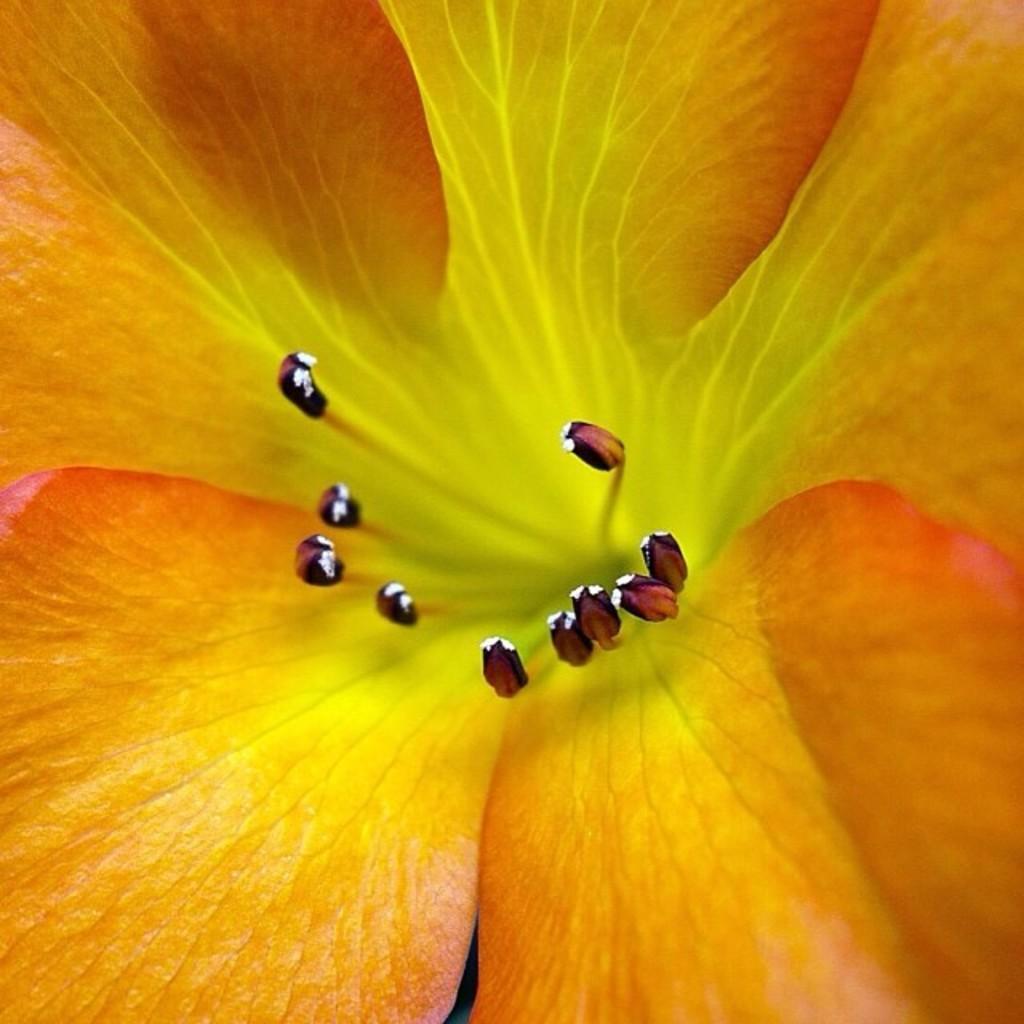How would you summarize this image in a sentence or two? In this image there is a flower. 